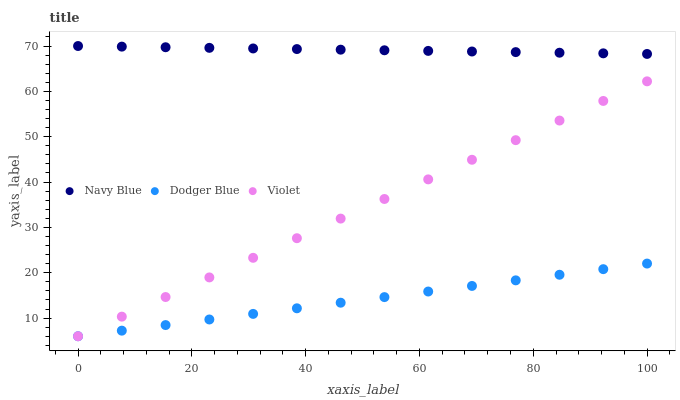Does Dodger Blue have the minimum area under the curve?
Answer yes or no. Yes. Does Navy Blue have the maximum area under the curve?
Answer yes or no. Yes. Does Violet have the minimum area under the curve?
Answer yes or no. No. Does Violet have the maximum area under the curve?
Answer yes or no. No. Is Dodger Blue the smoothest?
Answer yes or no. Yes. Is Navy Blue the roughest?
Answer yes or no. Yes. Is Violet the smoothest?
Answer yes or no. No. Is Violet the roughest?
Answer yes or no. No. Does Dodger Blue have the lowest value?
Answer yes or no. Yes. Does Navy Blue have the highest value?
Answer yes or no. Yes. Does Violet have the highest value?
Answer yes or no. No. Is Dodger Blue less than Navy Blue?
Answer yes or no. Yes. Is Navy Blue greater than Dodger Blue?
Answer yes or no. Yes. Does Violet intersect Dodger Blue?
Answer yes or no. Yes. Is Violet less than Dodger Blue?
Answer yes or no. No. Is Violet greater than Dodger Blue?
Answer yes or no. No. Does Dodger Blue intersect Navy Blue?
Answer yes or no. No. 